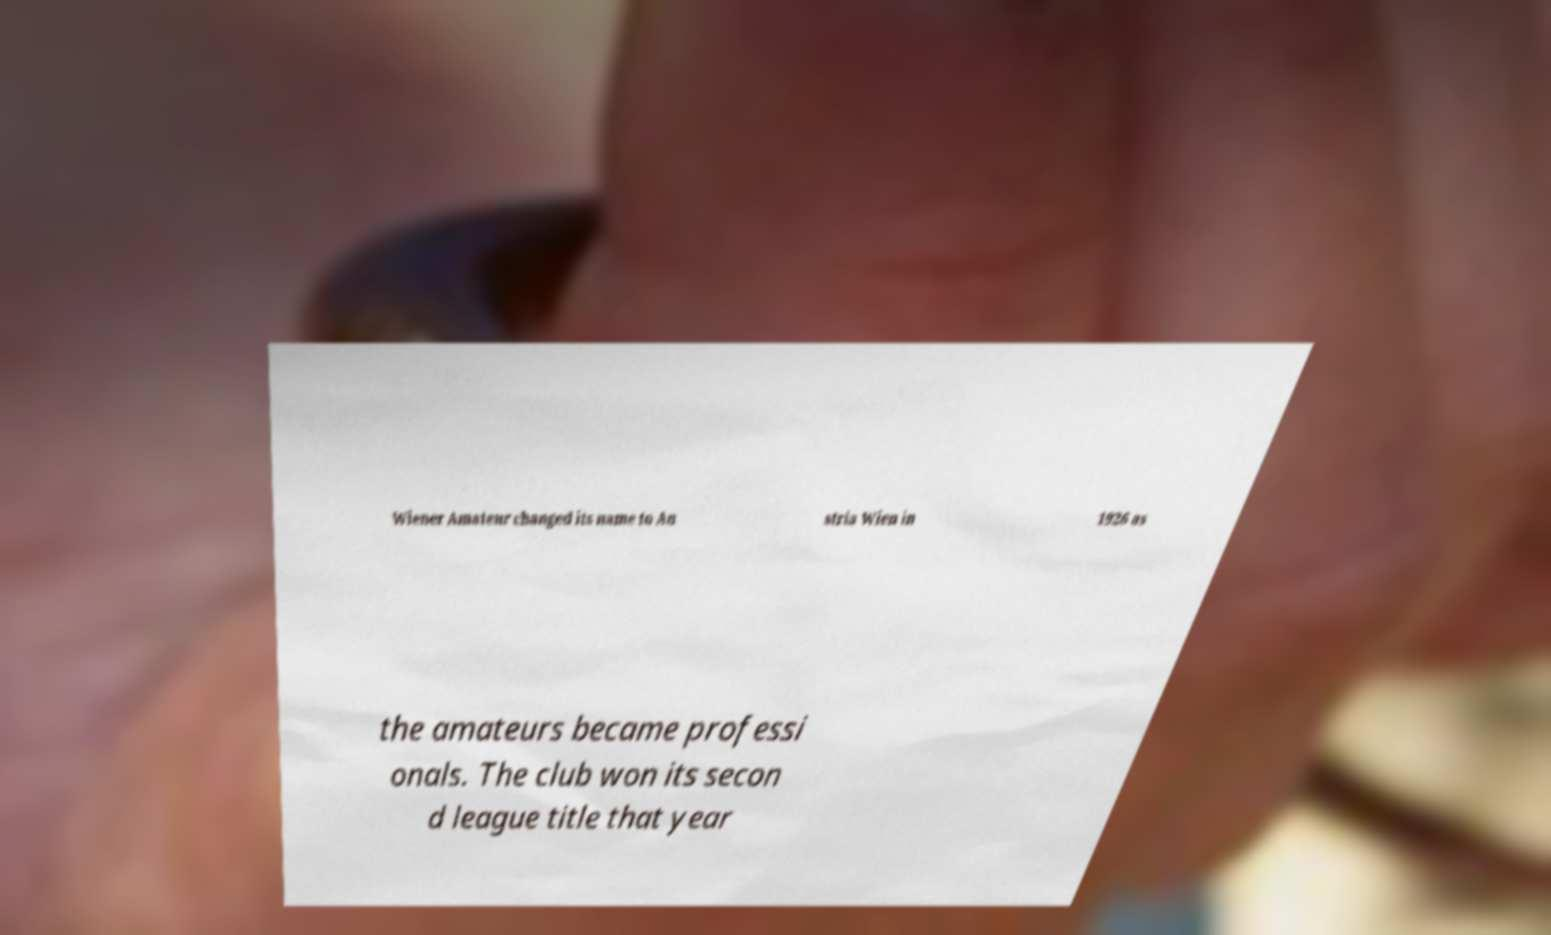Can you accurately transcribe the text from the provided image for me? Wiener Amateur changed its name to Au stria Wien in 1926 as the amateurs became professi onals. The club won its secon d league title that year 